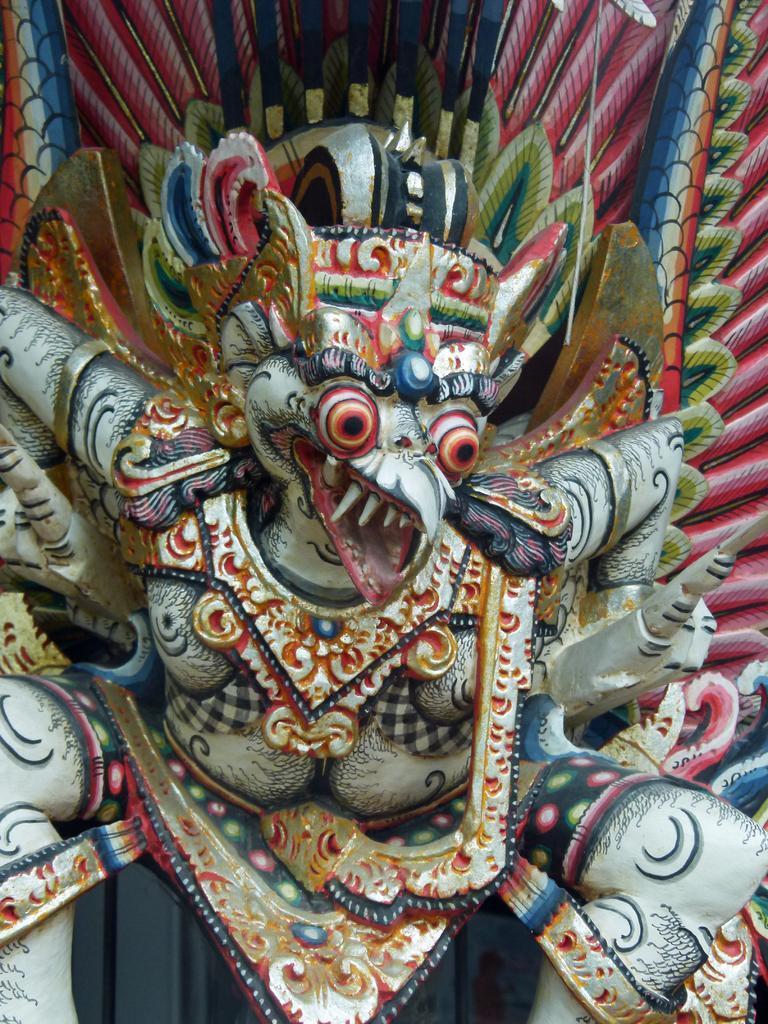Please provide a concise description of this image. In this image I can see a statue of a bird which is white, red, black, orange and gold in color. I can see two legs and two hands to the statue. In the background I can see its feathers which are red, blue and cream in color. 